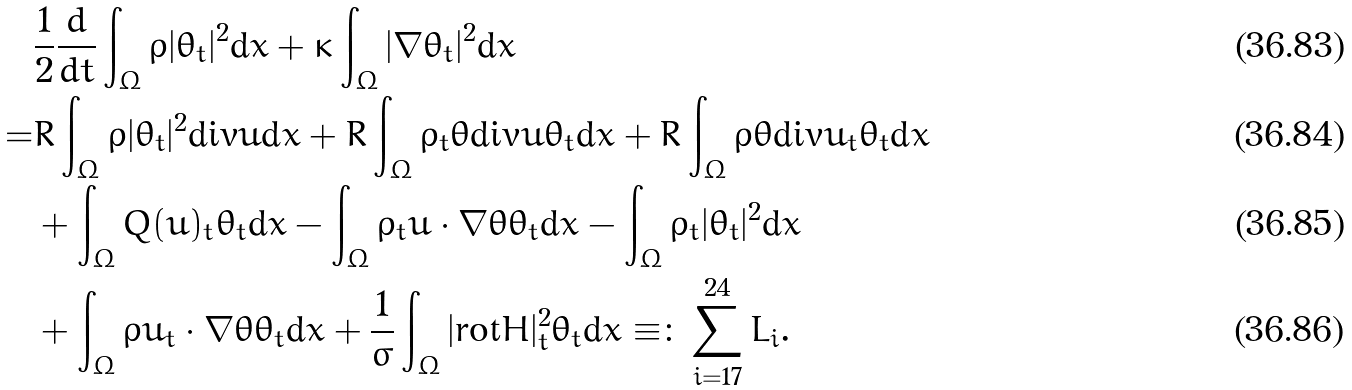<formula> <loc_0><loc_0><loc_500><loc_500>& \frac { 1 } { 2 } \frac { d } { d t } \int _ { \Omega } \rho | \theta _ { t } | ^ { 2 } \text {d} x + \kappa \int _ { \Omega } | \nabla \theta _ { t } | ^ { 2 } \text {d} x \\ = & R \int _ { \Omega } \rho | \theta _ { t } | ^ { 2 } \text {div} u \text {d} x + R \int _ { \Omega } \rho _ { t } \theta \text {div} u \theta _ { t } \text {d} x + R \int _ { \Omega } \rho \theta \text {div} u _ { t } \theta _ { t } \text {d} x \\ & + \int _ { \Omega } Q ( u ) _ { t } \theta _ { t } \text {d} x - \int _ { \Omega } \rho _ { t } u \cdot \nabla \theta \theta _ { t } \text {d} x - \int _ { \Omega } \rho _ { t } | \theta _ { t } | ^ { 2 } \text {d} x \\ & + \int _ { \Omega } \rho u _ { t } \cdot \nabla \theta \theta _ { t } \text {d} x + \frac { 1 } { \sigma } \int _ { \Omega } | \text {rot} H | ^ { 2 } _ { t } \theta _ { t } \text {d} x \equiv \colon \sum _ { i = 1 7 } ^ { 2 4 } L _ { i } .</formula> 